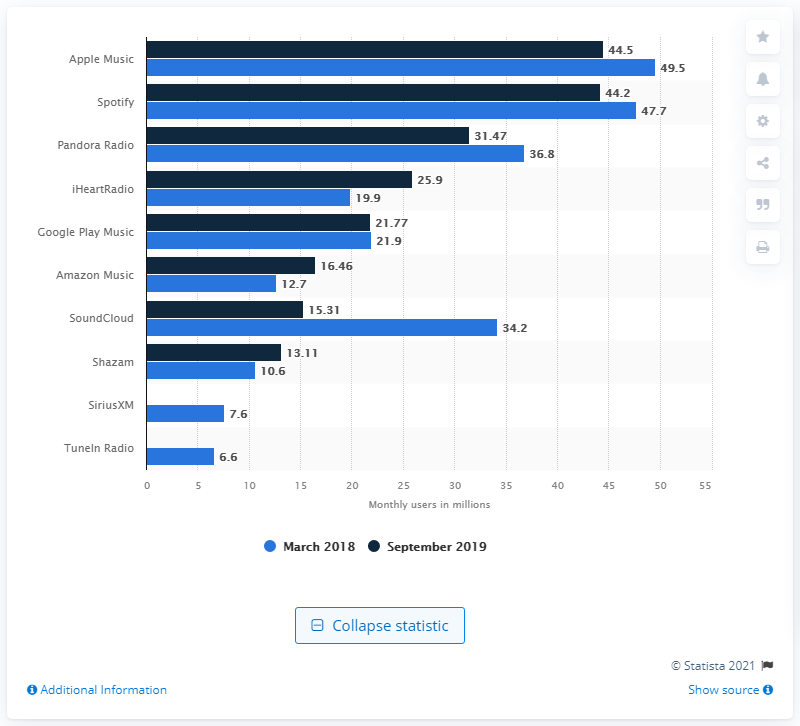Draw attention to some important aspects in this diagram. Apple Music is the most successful music streaming service in the US. As of March 2021, Spotify had approximately 47.7 monthly active users. Apple Music had approximately 49.5 users per month. 